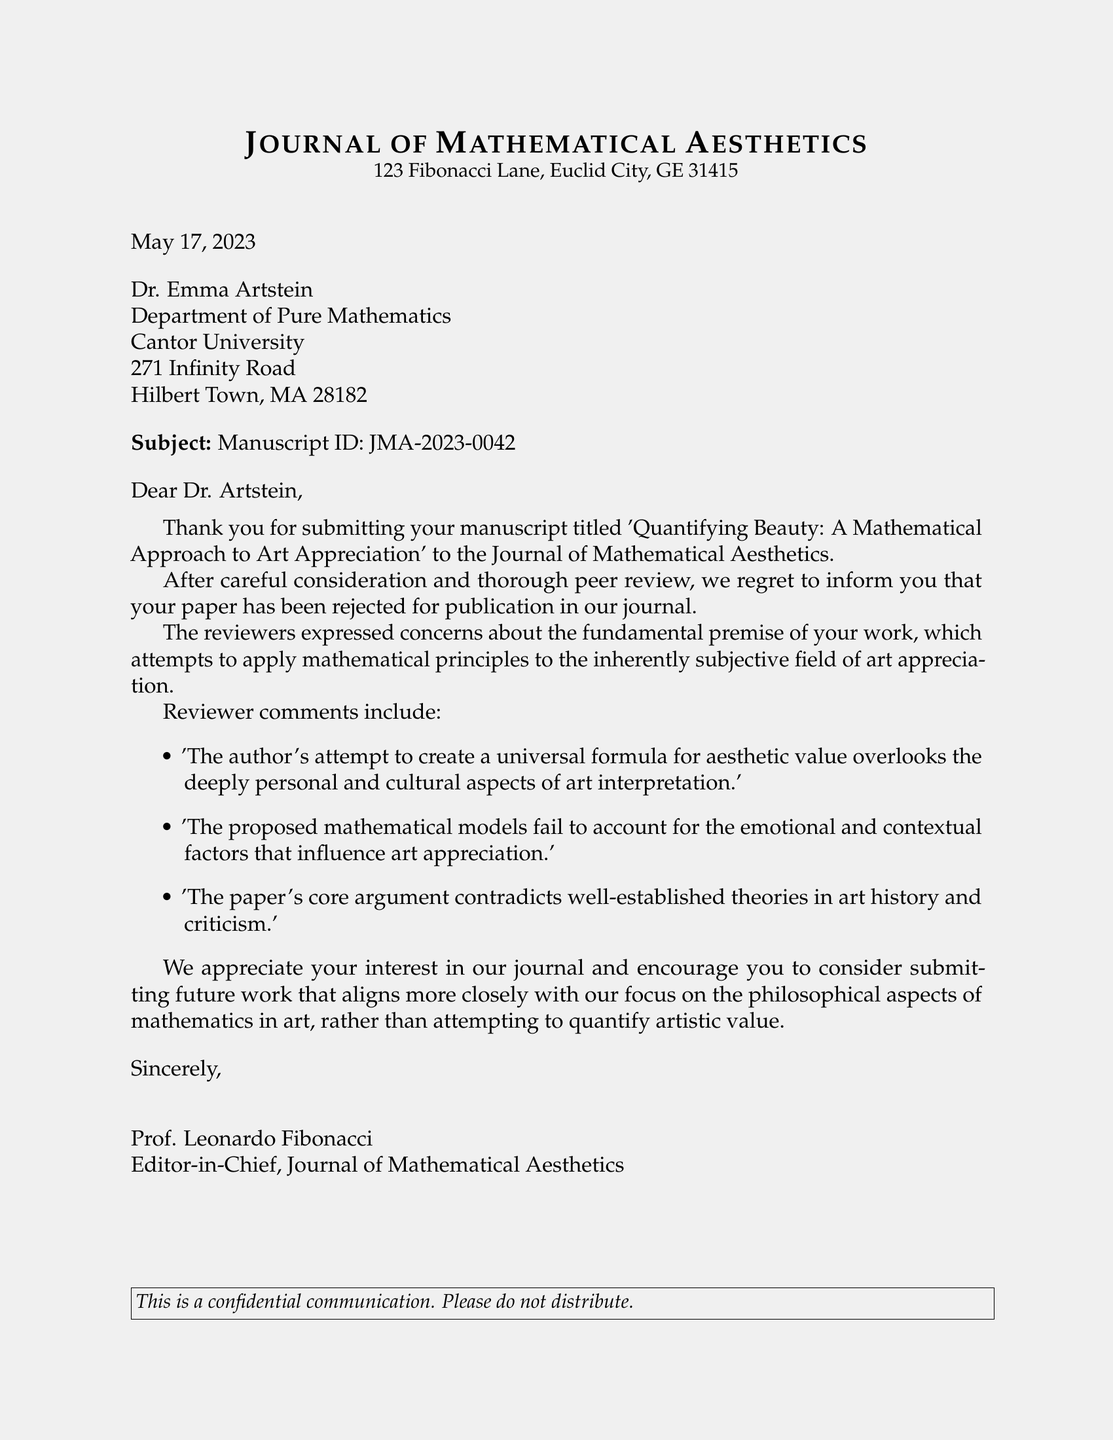What is the title of the manuscript? The title of the manuscript is clearly stated in the document as 'Quantifying Beauty: A Mathematical Approach to Art Appreciation'.
Answer: 'Quantifying Beauty: A Mathematical Approach to Art Appreciation' Who is the editor-in-chief of the journal? The name of the editor-in-chief is mentioned in the signature at the end of the document as Prof. Leonardo Fibonacci.
Answer: Prof. Leonardo Fibonacci What was the date of the letter? The date is provided at the beginning of the document as May 17, 2023.
Answer: May 17, 2023 What is the manuscript ID? The manuscript ID can be found in the subject line of the document, indicated as JMA-2023-0042.
Answer: JMA-2023-0042 What were the reviewers' concerns about the paper? The document lists three specific reviewer comments concerning the paper's premise and approach to art interpretation.
Answer: 'The author's attempt to create a universal formula for aesthetic value overlooks the deeply personal and cultural aspects of art interpretation.' What recommendation does the journal give for future submissions? The recommendation is to submit future work that focuses more closely on philosophical aspects of mathematics in art.
Answer: Aligns more closely with our focus on the philosophical aspects of mathematics in art What does the journal appreciate about the submitted manuscript? The journal appreciates the author's interest in their publication, as indicated in the letter.
Answer: Your interest in our journal How many reviewer comments are listed in the document? The document includes three reviewer comments regarding the manuscript.
Answer: Three 